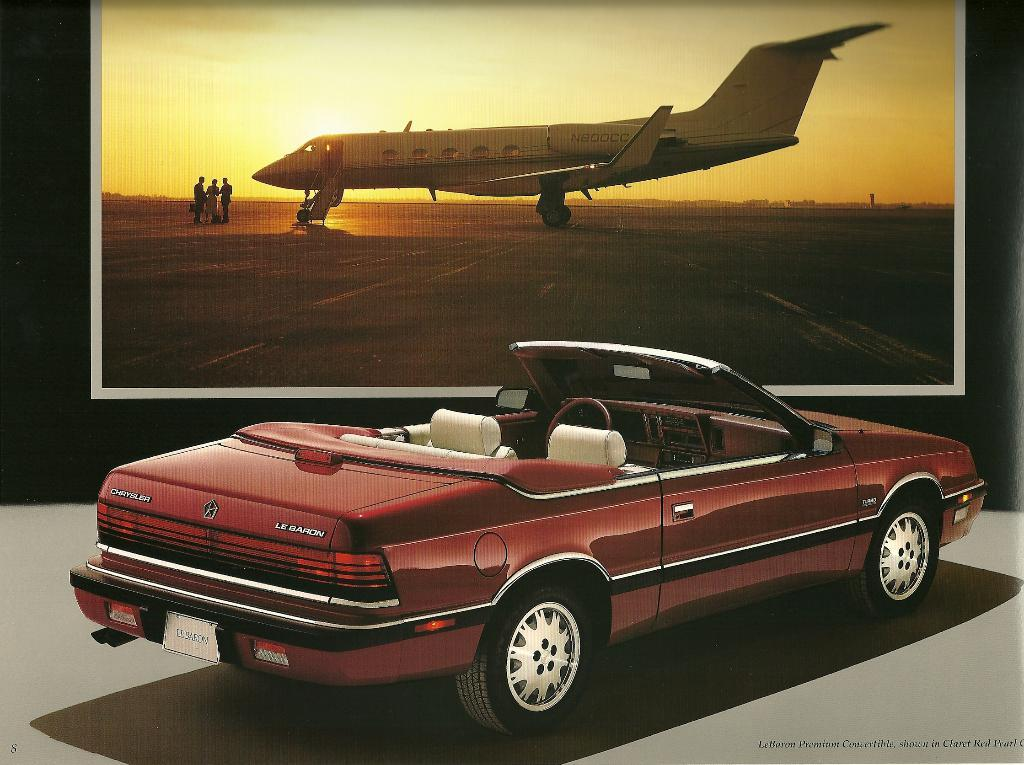<image>
Create a compact narrative representing the image presented. A red Chrysler Le baron is parked with its top down in front of a picture of a plane. 